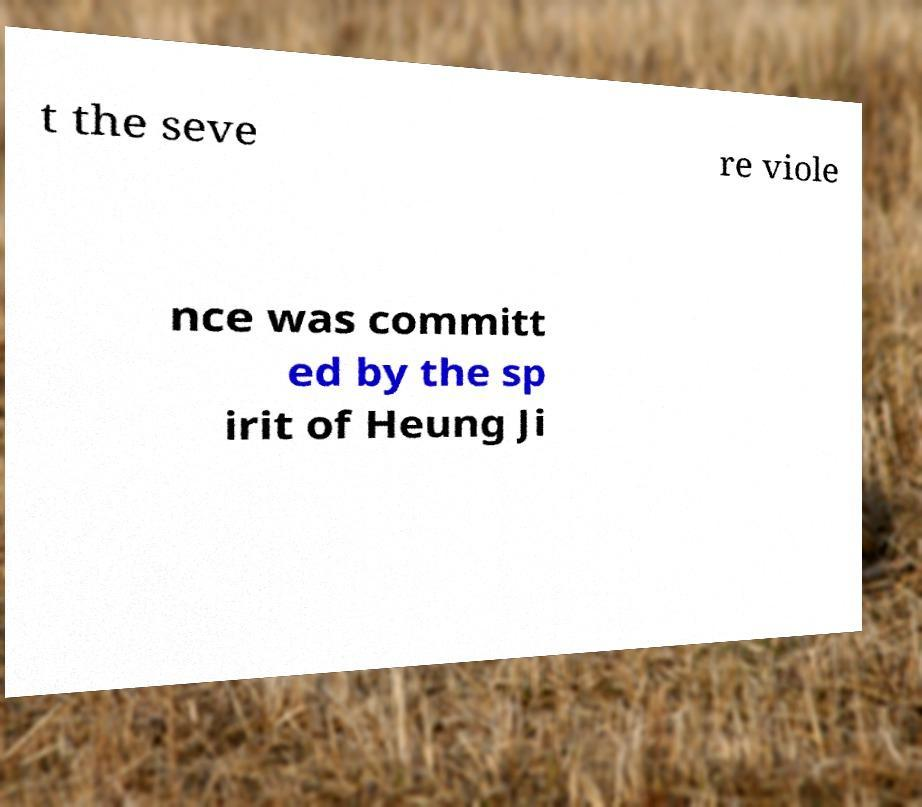There's text embedded in this image that I need extracted. Can you transcribe it verbatim? t the seve re viole nce was committ ed by the sp irit of Heung Ji 